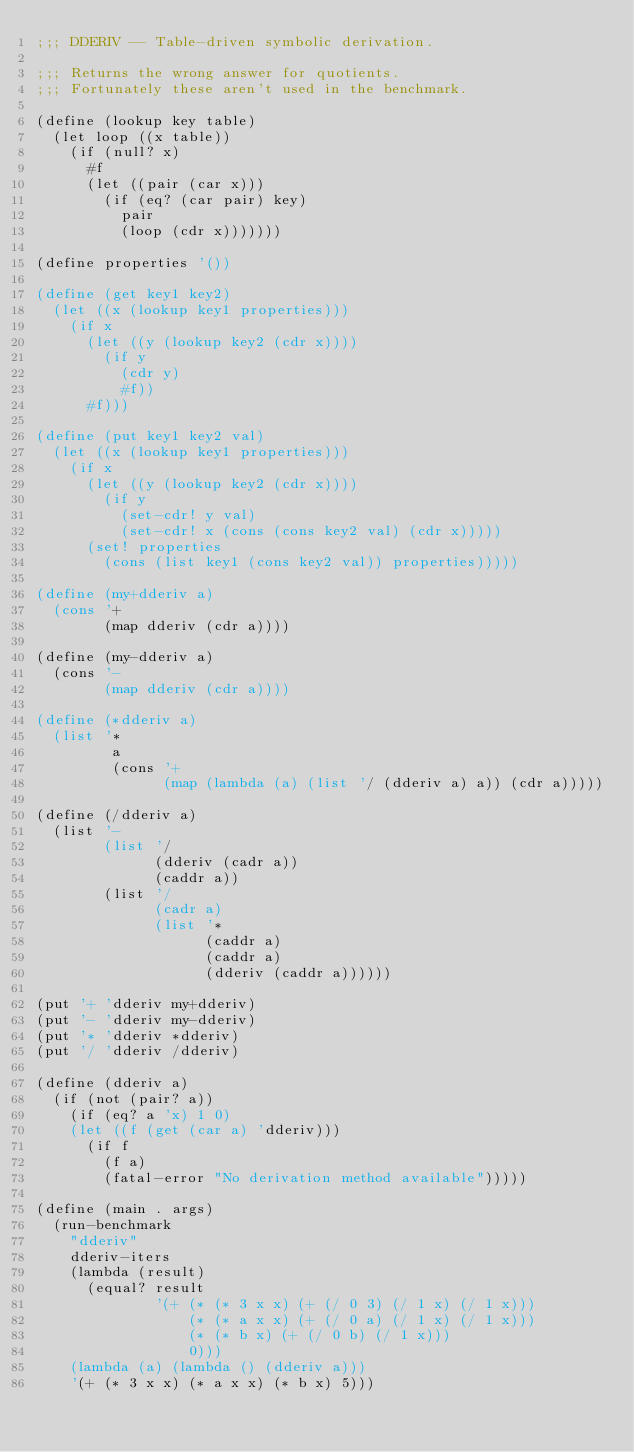Convert code to text. <code><loc_0><loc_0><loc_500><loc_500><_Scheme_>;;; DDERIV -- Table-driven symbolic derivation.

;;; Returns the wrong answer for quotients.
;;; Fortunately these aren't used in the benchmark.

(define (lookup key table)
  (let loop ((x table))
    (if (null? x)
      #f
      (let ((pair (car x)))
        (if (eq? (car pair) key)
          pair
          (loop (cdr x)))))))

(define properties '())

(define (get key1 key2)
  (let ((x (lookup key1 properties)))
    (if x
      (let ((y (lookup key2 (cdr x))))
        (if y
          (cdr y)
          #f))
      #f)))

(define (put key1 key2 val)
  (let ((x (lookup key1 properties)))
    (if x
      (let ((y (lookup key2 (cdr x))))
        (if y
          (set-cdr! y val)
          (set-cdr! x (cons (cons key2 val) (cdr x)))))
      (set! properties
        (cons (list key1 (cons key2 val)) properties)))))

(define (my+dderiv a)
  (cons '+
        (map dderiv (cdr a))))

(define (my-dderiv a)
  (cons '-
        (map dderiv (cdr a))))

(define (*dderiv a)
  (list '*
         a
         (cons '+
               (map (lambda (a) (list '/ (dderiv a) a)) (cdr a)))))

(define (/dderiv a)
  (list '-
        (list '/
              (dderiv (cadr a))
              (caddr a))
        (list '/
              (cadr a)
              (list '*
                    (caddr a)
                    (caddr a)
                    (dderiv (caddr a))))))

(put '+ 'dderiv my+dderiv)
(put '- 'dderiv my-dderiv)
(put '* 'dderiv *dderiv)
(put '/ 'dderiv /dderiv)

(define (dderiv a)
  (if (not (pair? a))
    (if (eq? a 'x) 1 0)
    (let ((f (get (car a) 'dderiv)))
      (if f
        (f a)
        (fatal-error "No derivation method available")))))

(define (main . args)
  (run-benchmark
    "dderiv"
    dderiv-iters
    (lambda (result)
      (equal? result
              '(+ (* (* 3 x x) (+ (/ 0 3) (/ 1 x) (/ 1 x)))
                  (* (* a x x) (+ (/ 0 a) (/ 1 x) (/ 1 x)))
                  (* (* b x) (+ (/ 0 b) (/ 1 x)))
                  0)))
    (lambda (a) (lambda () (dderiv a)))
    '(+ (* 3 x x) (* a x x) (* b x) 5)))
</code> 